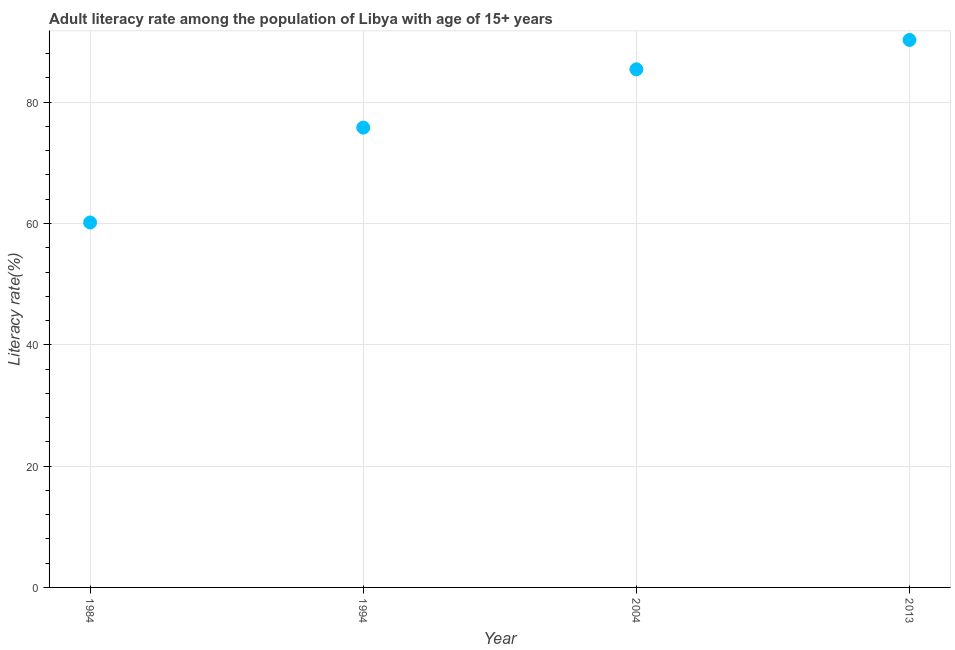What is the adult literacy rate in 1984?
Make the answer very short. 60.16. Across all years, what is the maximum adult literacy rate?
Offer a terse response. 90.26. Across all years, what is the minimum adult literacy rate?
Offer a terse response. 60.16. In which year was the adult literacy rate maximum?
Provide a short and direct response. 2013. In which year was the adult literacy rate minimum?
Your answer should be compact. 1984. What is the sum of the adult literacy rate?
Provide a short and direct response. 311.65. What is the difference between the adult literacy rate in 1984 and 1994?
Make the answer very short. -15.64. What is the average adult literacy rate per year?
Provide a succinct answer. 77.91. What is the median adult literacy rate?
Your answer should be compact. 80.61. In how many years, is the adult literacy rate greater than 60 %?
Your answer should be compact. 4. What is the ratio of the adult literacy rate in 1984 to that in 1994?
Provide a short and direct response. 0.79. What is the difference between the highest and the second highest adult literacy rate?
Provide a succinct answer. 4.84. What is the difference between the highest and the lowest adult literacy rate?
Make the answer very short. 30.09. Are the values on the major ticks of Y-axis written in scientific E-notation?
Provide a succinct answer. No. Does the graph contain any zero values?
Provide a succinct answer. No. What is the title of the graph?
Offer a very short reply. Adult literacy rate among the population of Libya with age of 15+ years. What is the label or title of the X-axis?
Your answer should be compact. Year. What is the label or title of the Y-axis?
Ensure brevity in your answer.  Literacy rate(%). What is the Literacy rate(%) in 1984?
Make the answer very short. 60.16. What is the Literacy rate(%) in 1994?
Give a very brief answer. 75.81. What is the Literacy rate(%) in 2004?
Provide a short and direct response. 85.42. What is the Literacy rate(%) in 2013?
Your response must be concise. 90.26. What is the difference between the Literacy rate(%) in 1984 and 1994?
Your answer should be compact. -15.64. What is the difference between the Literacy rate(%) in 1984 and 2004?
Your answer should be compact. -25.25. What is the difference between the Literacy rate(%) in 1984 and 2013?
Give a very brief answer. -30.09. What is the difference between the Literacy rate(%) in 1994 and 2004?
Your answer should be very brief. -9.61. What is the difference between the Literacy rate(%) in 1994 and 2013?
Your answer should be compact. -14.45. What is the difference between the Literacy rate(%) in 2004 and 2013?
Provide a short and direct response. -4.84. What is the ratio of the Literacy rate(%) in 1984 to that in 1994?
Offer a very short reply. 0.79. What is the ratio of the Literacy rate(%) in 1984 to that in 2004?
Provide a succinct answer. 0.7. What is the ratio of the Literacy rate(%) in 1984 to that in 2013?
Offer a terse response. 0.67. What is the ratio of the Literacy rate(%) in 1994 to that in 2004?
Provide a succinct answer. 0.89. What is the ratio of the Literacy rate(%) in 1994 to that in 2013?
Keep it short and to the point. 0.84. What is the ratio of the Literacy rate(%) in 2004 to that in 2013?
Keep it short and to the point. 0.95. 